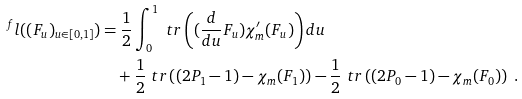Convert formula to latex. <formula><loc_0><loc_0><loc_500><loc_500>^ { f } l ( ( F _ { u } ) _ { u \in [ 0 , 1 ] } ) & = \frac { 1 } { 2 } \int _ { 0 } ^ { 1 } \ t r \left ( ( \frac { d } { d u } F _ { u } ) \chi _ { m } ^ { \prime } ( F _ { u } ) \right ) d u \\ & \quad + \frac { 1 } { 2 } \ t r \left ( ( 2 P _ { 1 } - 1 ) - \chi _ { m } ( F _ { 1 } ) \right ) - \frac { 1 } { 2 } \ t r \left ( ( 2 P _ { 0 } - 1 ) - \chi _ { m } ( F _ { 0 } ) \right ) \ .</formula> 